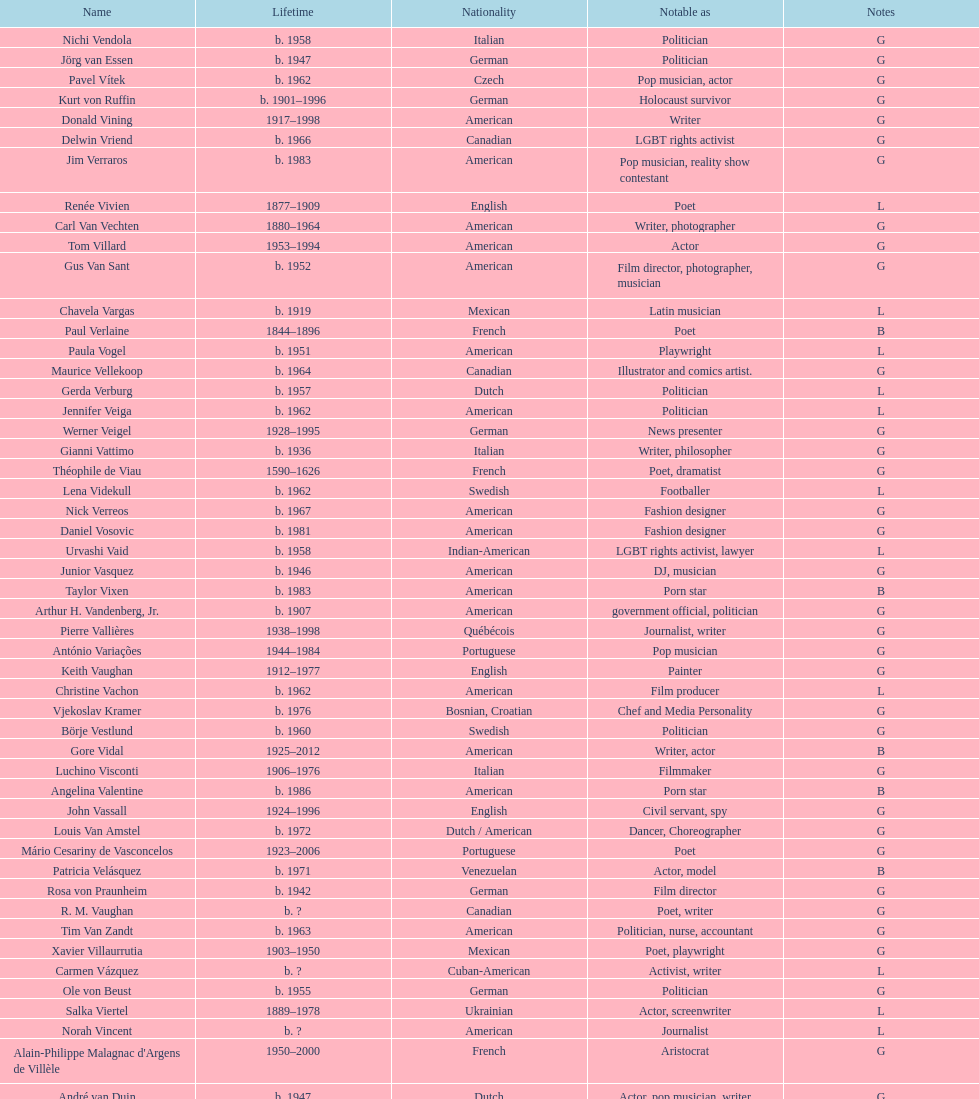What is the number of individuals in this group who were indian? 1. 